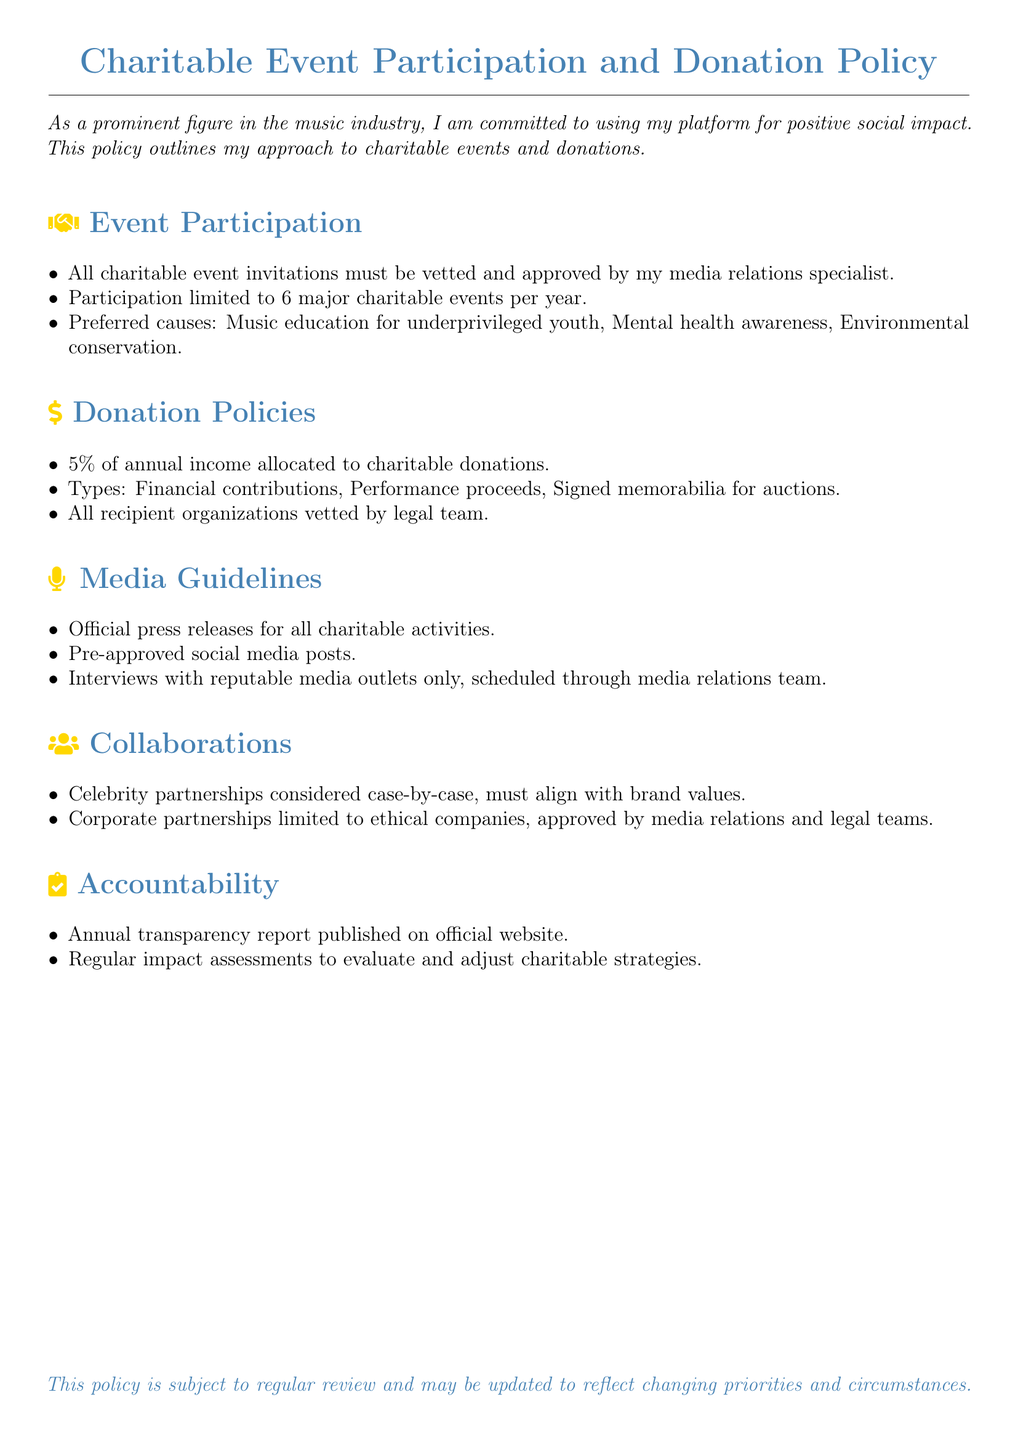What is the maximum number of major charitable events per year? The document specifies that participation is limited to 6 major charitable events per year.
Answer: 6 What percentage of annual income is allocated to charitable donations? The policy states that 5% of annual income is allocated to charitable donations.
Answer: 5% What types of contributions are mentioned in the donation policies? The document lists financial contributions, performance proceeds, and signed memorabilia for auctions as types of contributions.
Answer: Financial contributions, Performance proceeds, Signed memorabilia for auctions Who must vet all charitable event invitations? The document mentions that all charitable event invitations must be vetted and approved by the media relations specialist.
Answer: Media relations specialist What does the annual transparency report published reflect? The annual transparency report reflects the accountability aspect of the policy, evaluating and disclosing charitable activities.
Answer: Charitable activities What is the focus of preferred causes for participation? The preferred causes outlined in the policy include music education for underprivileged youth, mental health awareness, and environmental conservation.
Answer: Music education, Mental health awareness, Environmental conservation What is the requirement for celebrity partnerships? The document states that celebrity partnerships are considered case-by-case and must align with brand values.
Answer: Case-by-case, align with brand values Which teams must approve corporate partnerships? According to the document, corporate partnerships must be approved by the media relations and legal teams.
Answer: Media relations and legal teams 